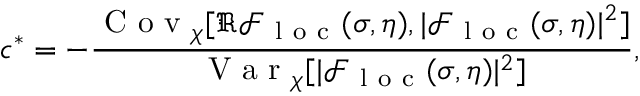<formula> <loc_0><loc_0><loc_500><loc_500>c ^ { * } = - \frac { C o v _ { \chi } [ \Re \mathcal { F } _ { l o c } ( \sigma , \eta ) , | \mathcal { F } _ { l o c } ( \sigma , \eta ) | ^ { 2 } ] } { V a r _ { \chi } [ | \mathcal { F } _ { l o c } ( \sigma , \eta ) | ^ { 2 } ] } ,</formula> 